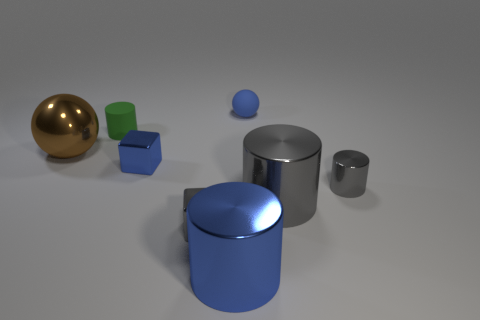Are there more cubes that are behind the small gray shiny cylinder than brown spheres right of the small blue ball? Yes, there are more cubes positioned behind the small gray cylinder when compared to the brown spheres located to the right of the small blue ball. Specifically, there are two cubes behind the cylinder and only one brown sphere next to the blue ball. 